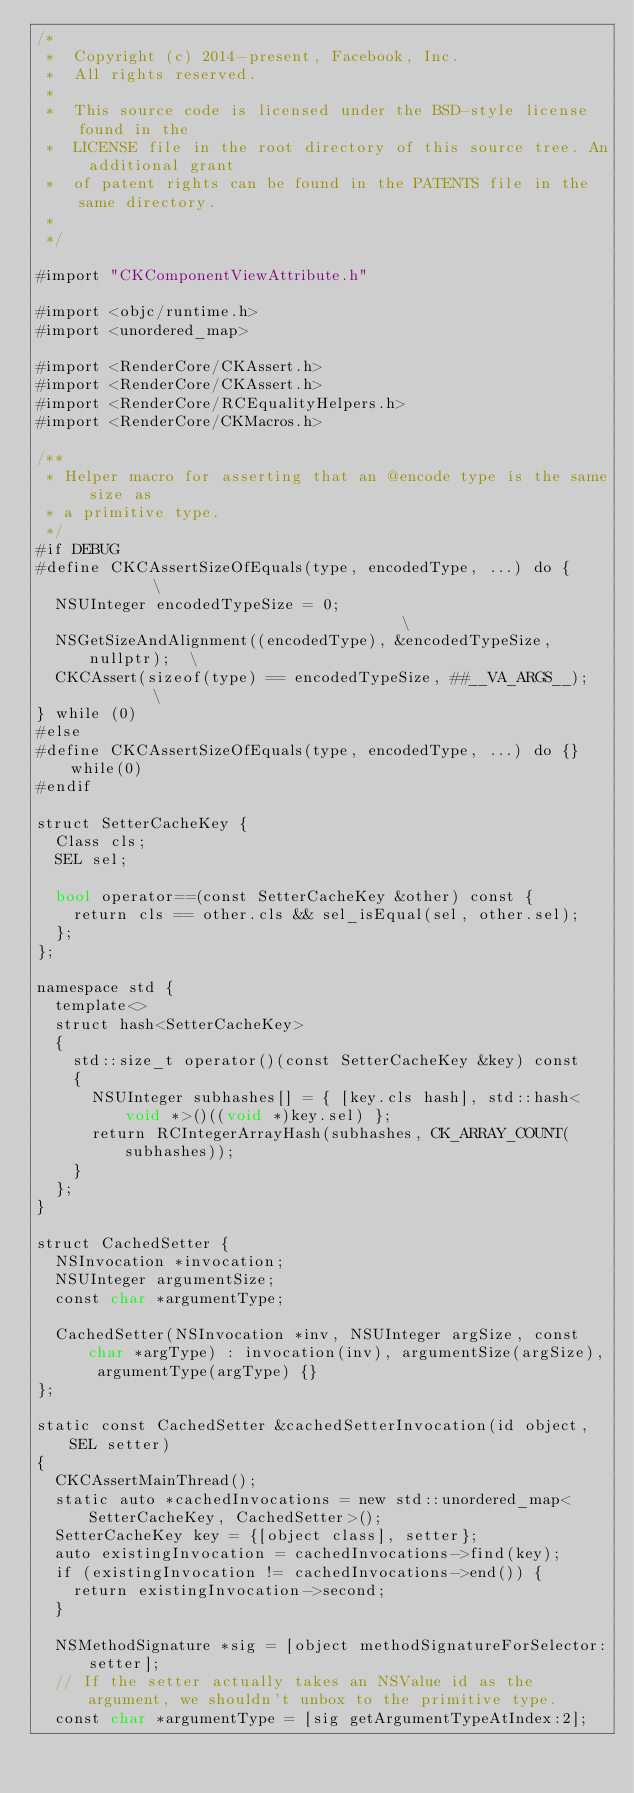<code> <loc_0><loc_0><loc_500><loc_500><_ObjectiveC_>/*
 *  Copyright (c) 2014-present, Facebook, Inc.
 *  All rights reserved.
 *
 *  This source code is licensed under the BSD-style license found in the
 *  LICENSE file in the root directory of this source tree. An additional grant
 *  of patent rights can be found in the PATENTS file in the same directory.
 *
 */

#import "CKComponentViewAttribute.h"

#import <objc/runtime.h>
#import <unordered_map>

#import <RenderCore/CKAssert.h>
#import <RenderCore/CKAssert.h>
#import <RenderCore/RCEqualityHelpers.h>
#import <RenderCore/CKMacros.h>

/**
 * Helper macro for asserting that an @encode type is the same size as
 * a primitive type.
 */
#if DEBUG
#define CKCAssertSizeOfEquals(type, encodedType, ...) do {          \
  NSUInteger encodedTypeSize = 0;                                   \
  NSGetSizeAndAlignment((encodedType), &encodedTypeSize, nullptr);  \
  CKCAssert(sizeof(type) == encodedTypeSize, ##__VA_ARGS__);        \
} while (0)
#else
#define CKCAssertSizeOfEquals(type, encodedType, ...) do {} while(0)
#endif

struct SetterCacheKey {
  Class cls;
  SEL sel;

  bool operator==(const SetterCacheKey &other) const {
    return cls == other.cls && sel_isEqual(sel, other.sel);
  };
};

namespace std {
  template<>
  struct hash<SetterCacheKey>
  {
    std::size_t operator()(const SetterCacheKey &key) const
    {
      NSUInteger subhashes[] = { [key.cls hash], std::hash<void *>()((void *)key.sel) };
      return RCIntegerArrayHash(subhashes, CK_ARRAY_COUNT(subhashes));
    }
  };
}

struct CachedSetter {
  NSInvocation *invocation;
  NSUInteger argumentSize;
  const char *argumentType;

  CachedSetter(NSInvocation *inv, NSUInteger argSize, const char *argType) : invocation(inv), argumentSize(argSize), argumentType(argType) {}
};

static const CachedSetter &cachedSetterInvocation(id object, SEL setter)
{
  CKCAssertMainThread();
  static auto *cachedInvocations = new std::unordered_map<SetterCacheKey, CachedSetter>();
  SetterCacheKey key = {[object class], setter};
  auto existingInvocation = cachedInvocations->find(key);
  if (existingInvocation != cachedInvocations->end()) {
    return existingInvocation->second;
  }

  NSMethodSignature *sig = [object methodSignatureForSelector:setter];
  // If the setter actually takes an NSValue id as the argument, we shouldn't unbox to the primitive type.
  const char *argumentType = [sig getArgumentTypeAtIndex:2];</code> 